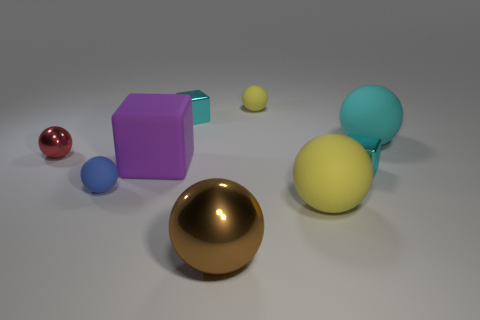Subtract 3 spheres. How many spheres are left? 3 Subtract all cyan balls. How many balls are left? 5 Subtract all red metal balls. How many balls are left? 5 Subtract all gray spheres. Subtract all green blocks. How many spheres are left? 6 Add 1 red shiny cubes. How many objects exist? 10 Subtract all blocks. How many objects are left? 6 Add 5 big gray rubber spheres. How many big gray rubber spheres exist? 5 Subtract 0 cyan cylinders. How many objects are left? 9 Subtract all big yellow rubber balls. Subtract all big matte balls. How many objects are left? 6 Add 8 red balls. How many red balls are left? 9 